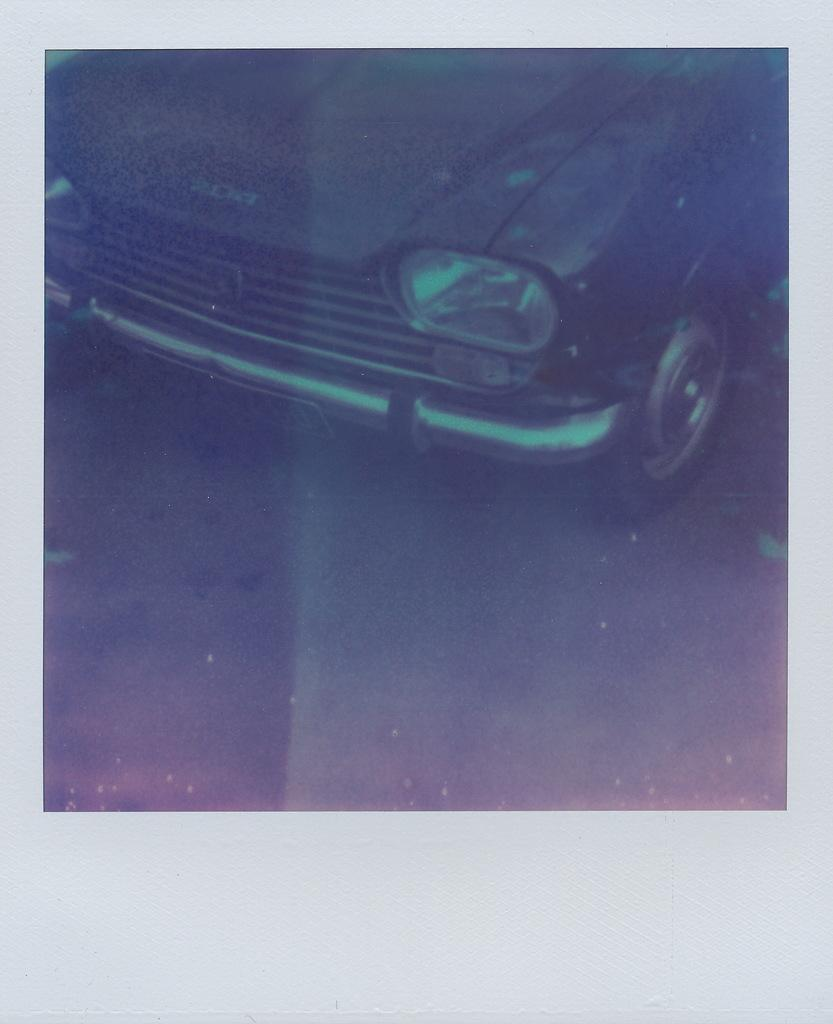What is the main subject of the image? The main subject of the image is an old photograph of a car. What color is the car in the photograph? The car in the photograph is black in color. Where is the car located in the photograph? The car is on the ground in the photograph. What can be seen around the photograph in the image? There are grey colored boundaries around the photograph. What type of rod is used for digestion in the image? There is no rod or reference to digestion present in the image. 